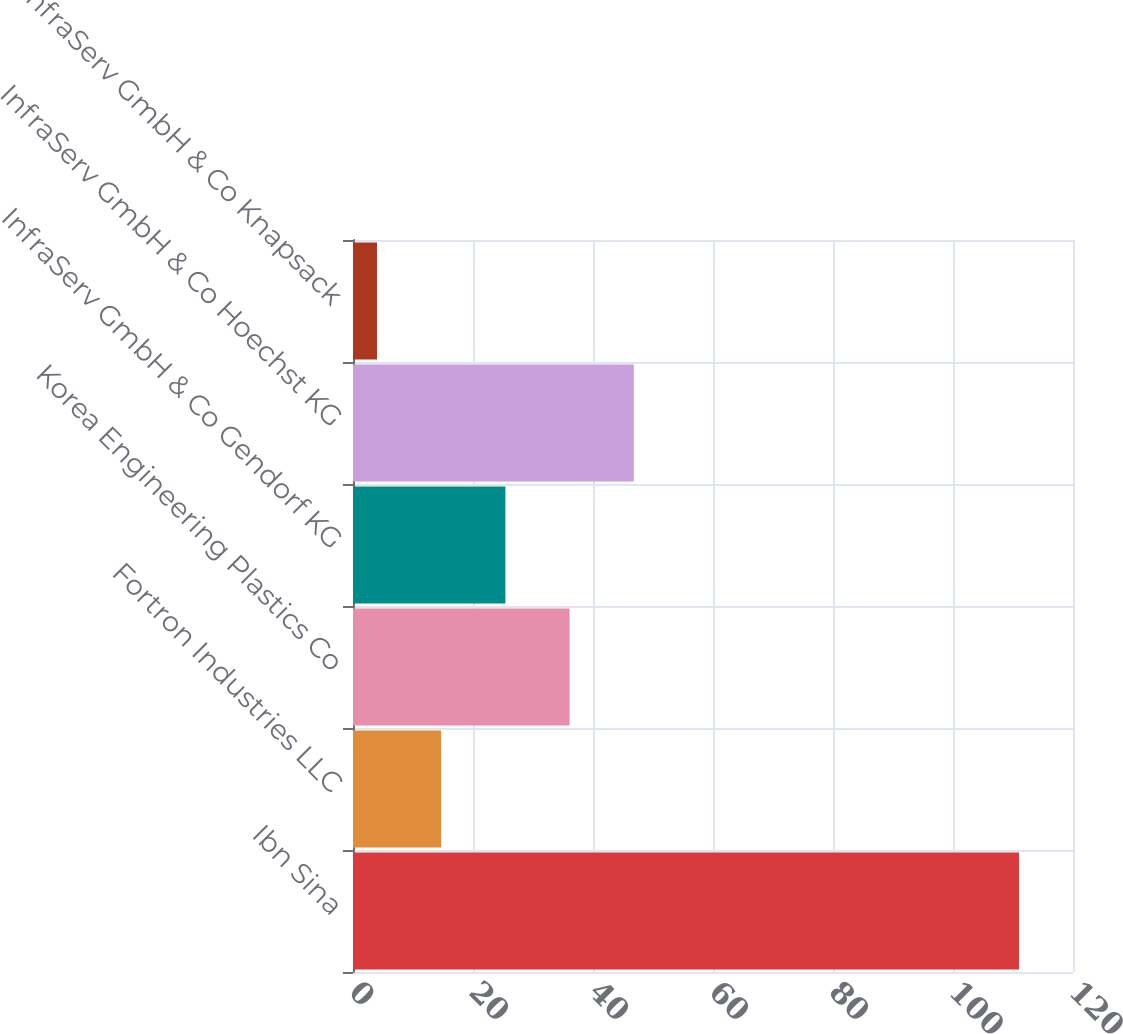<chart> <loc_0><loc_0><loc_500><loc_500><bar_chart><fcel>Ibn Sina<fcel>Fortron Industries LLC<fcel>Korea Engineering Plastics Co<fcel>InfraServ GmbH & Co Gendorf KG<fcel>InfraServ GmbH & Co Hoechst KG<fcel>InfraServ GmbH & Co Knapsack<nl><fcel>111<fcel>14.7<fcel>36.1<fcel>25.4<fcel>46.8<fcel>4<nl></chart> 